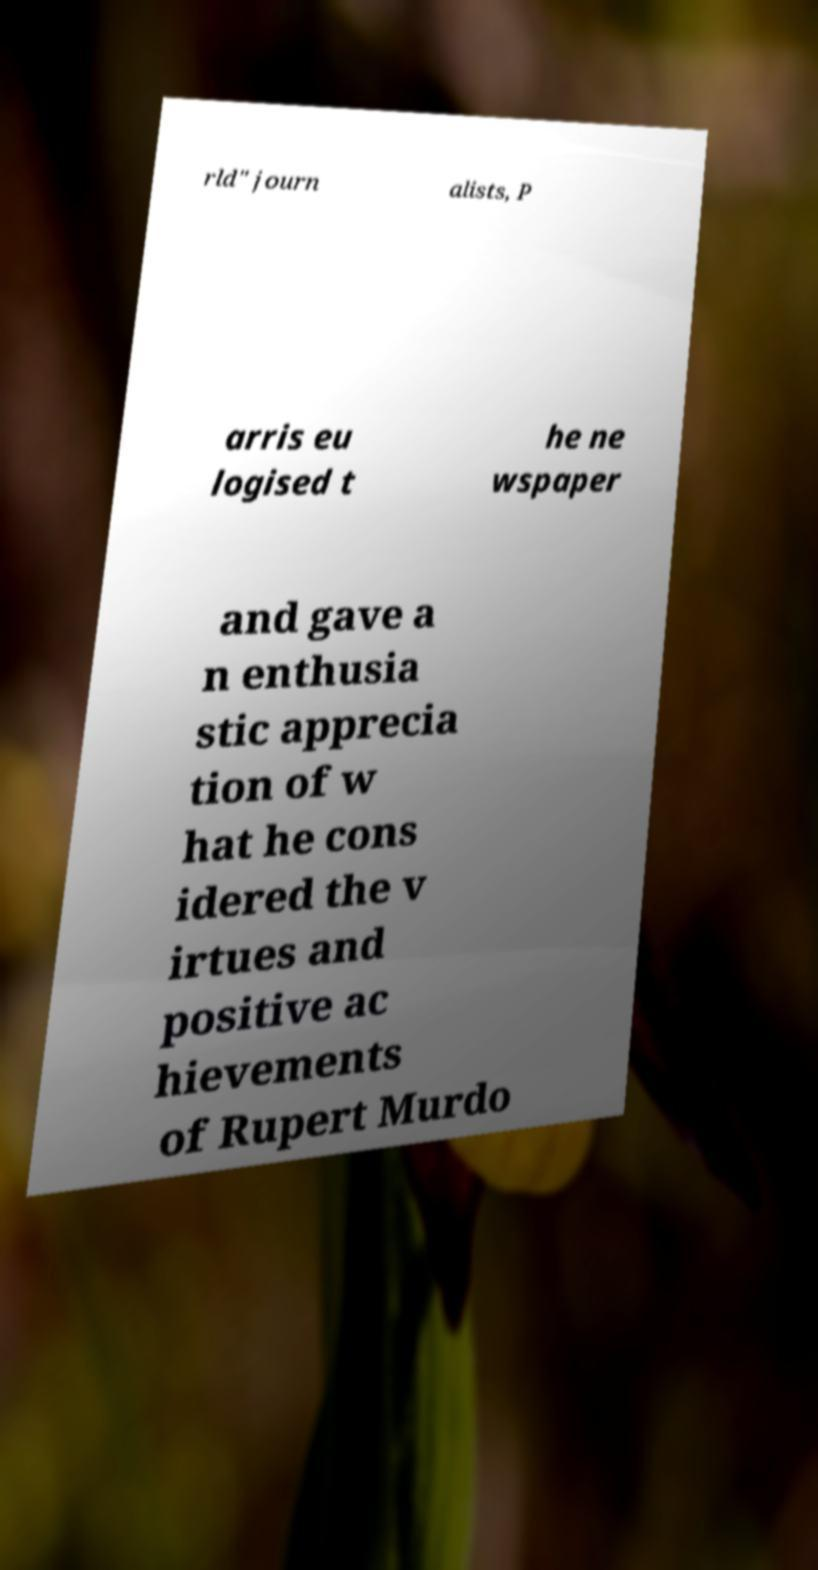What messages or text are displayed in this image? I need them in a readable, typed format. rld" journ alists, P arris eu logised t he ne wspaper and gave a n enthusia stic apprecia tion of w hat he cons idered the v irtues and positive ac hievements of Rupert Murdo 